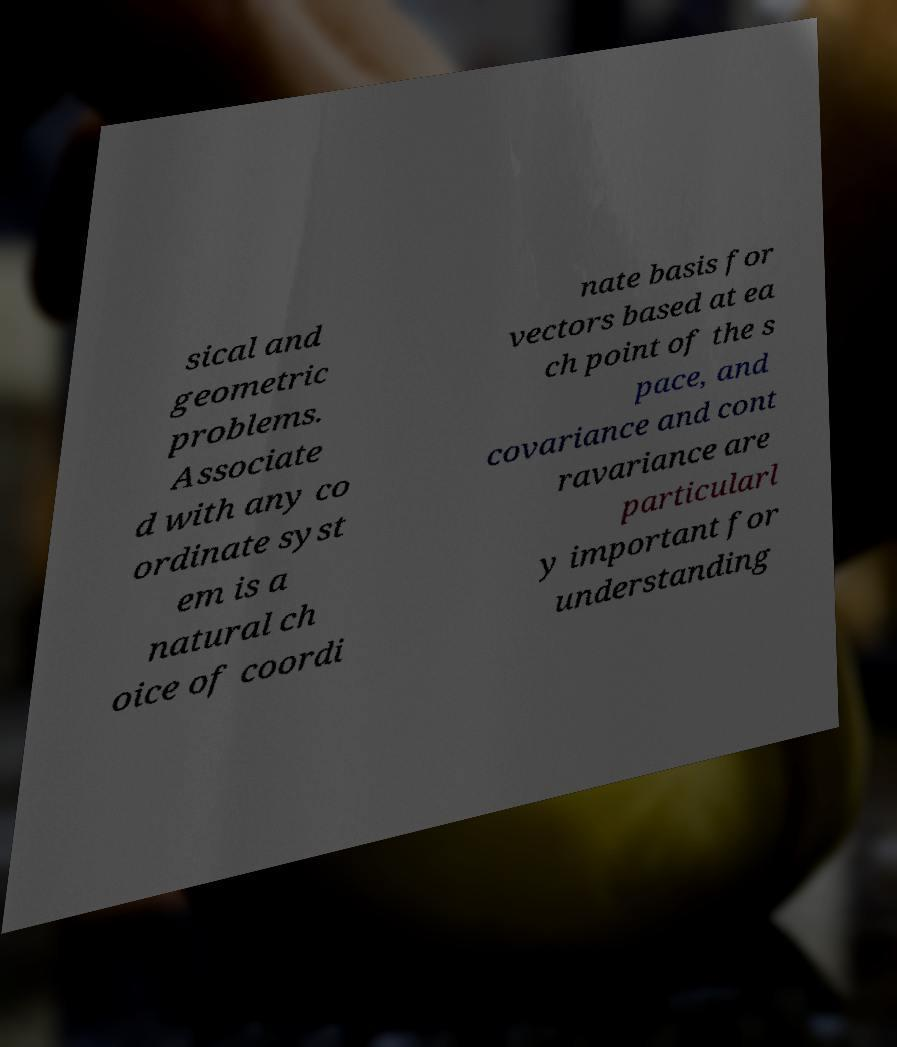Can you accurately transcribe the text from the provided image for me? sical and geometric problems. Associate d with any co ordinate syst em is a natural ch oice of coordi nate basis for vectors based at ea ch point of the s pace, and covariance and cont ravariance are particularl y important for understanding 